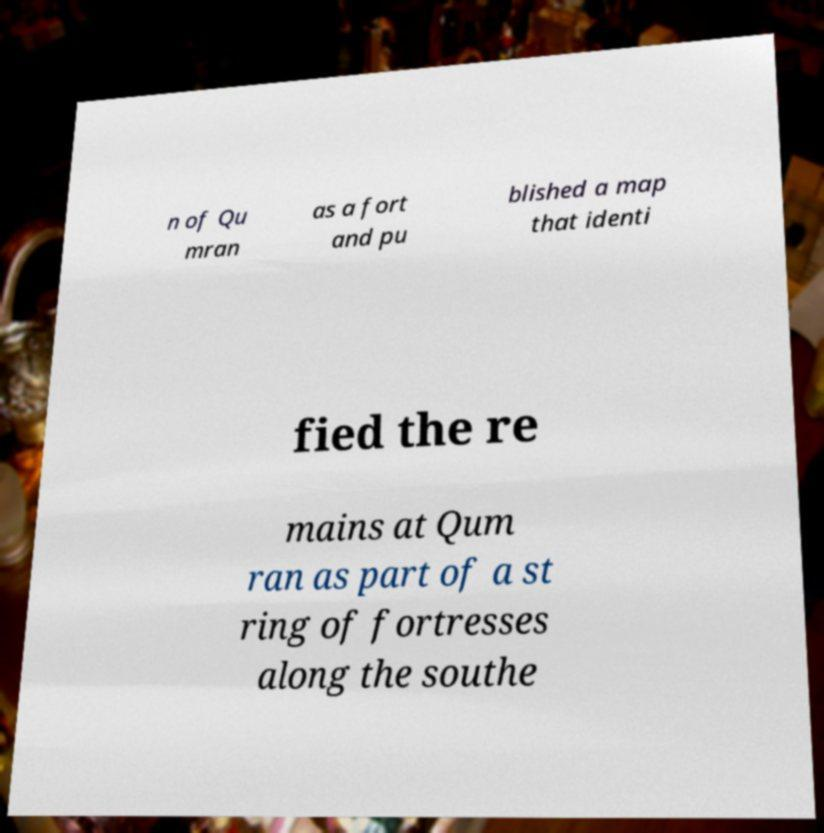Please read and relay the text visible in this image. What does it say? n of Qu mran as a fort and pu blished a map that identi fied the re mains at Qum ran as part of a st ring of fortresses along the southe 